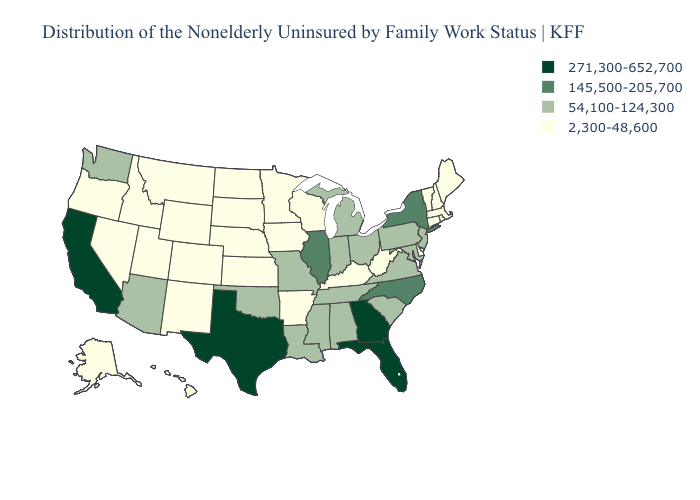What is the value of Tennessee?
Be succinct. 54,100-124,300. What is the value of Iowa?
Concise answer only. 2,300-48,600. What is the lowest value in the Northeast?
Write a very short answer. 2,300-48,600. What is the value of California?
Short answer required. 271,300-652,700. Which states hav the highest value in the MidWest?
Be succinct. Illinois. Does Oregon have the lowest value in the USA?
Write a very short answer. Yes. What is the value of Mississippi?
Short answer required. 54,100-124,300. What is the lowest value in the Northeast?
Quick response, please. 2,300-48,600. What is the lowest value in the MidWest?
Short answer required. 2,300-48,600. Among the states that border New York , does Massachusetts have the highest value?
Write a very short answer. No. Does Missouri have the lowest value in the MidWest?
Keep it brief. No. How many symbols are there in the legend?
Concise answer only. 4. Does Kentucky have a lower value than Alabama?
Answer briefly. Yes. What is the value of Ohio?
Be succinct. 54,100-124,300. 